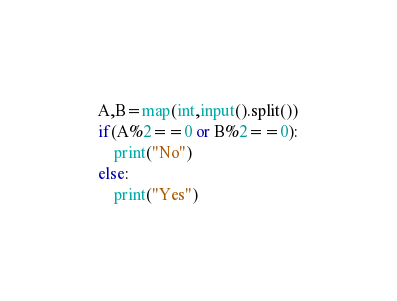<code> <loc_0><loc_0><loc_500><loc_500><_Python_>A,B=map(int,input().split())
if(A%2==0 or B%2==0):
    print("No")
else:
    print("Yes")</code> 